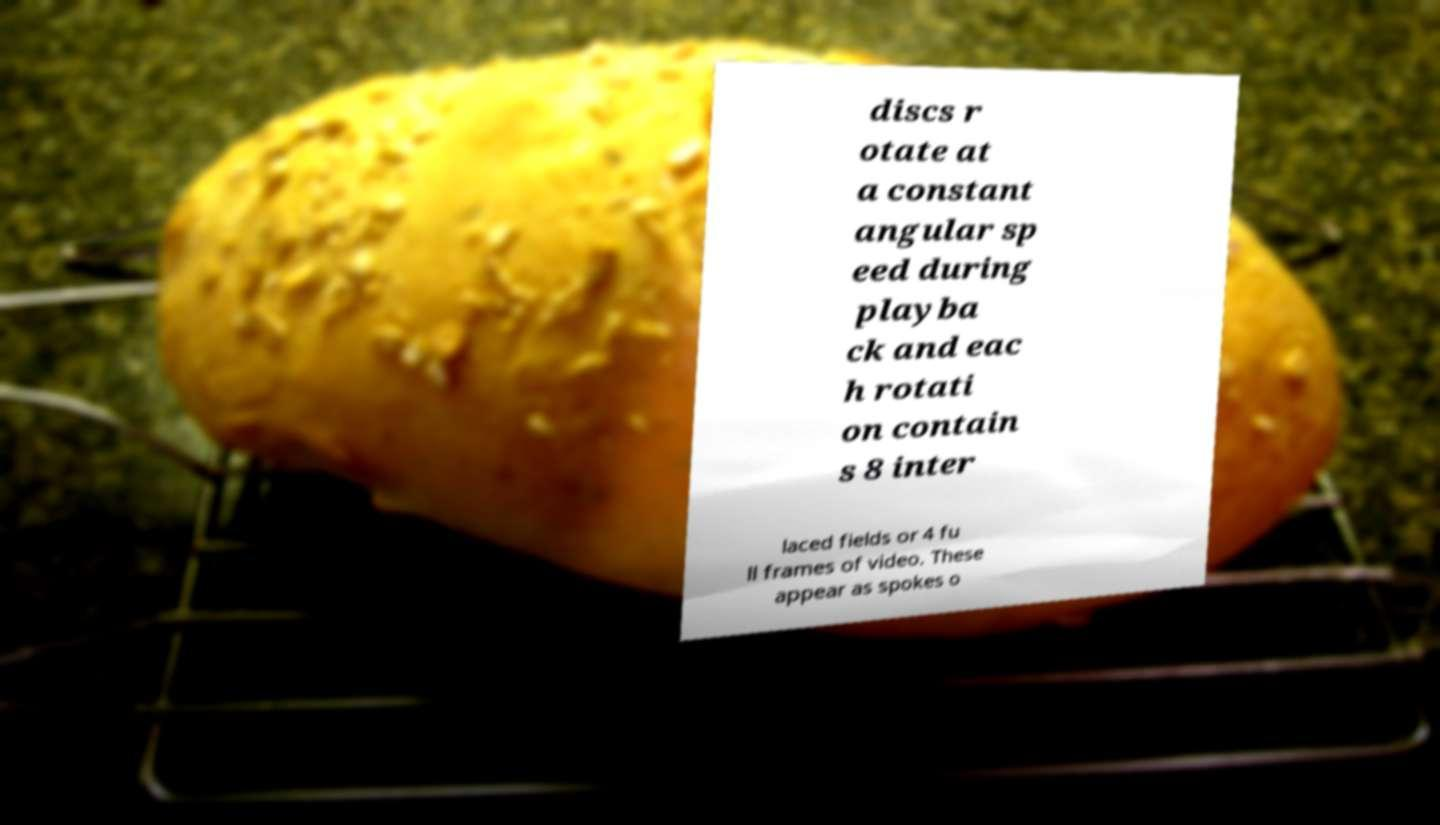Could you extract and type out the text from this image? discs r otate at a constant angular sp eed during playba ck and eac h rotati on contain s 8 inter laced fields or 4 fu ll frames of video. These appear as spokes o 